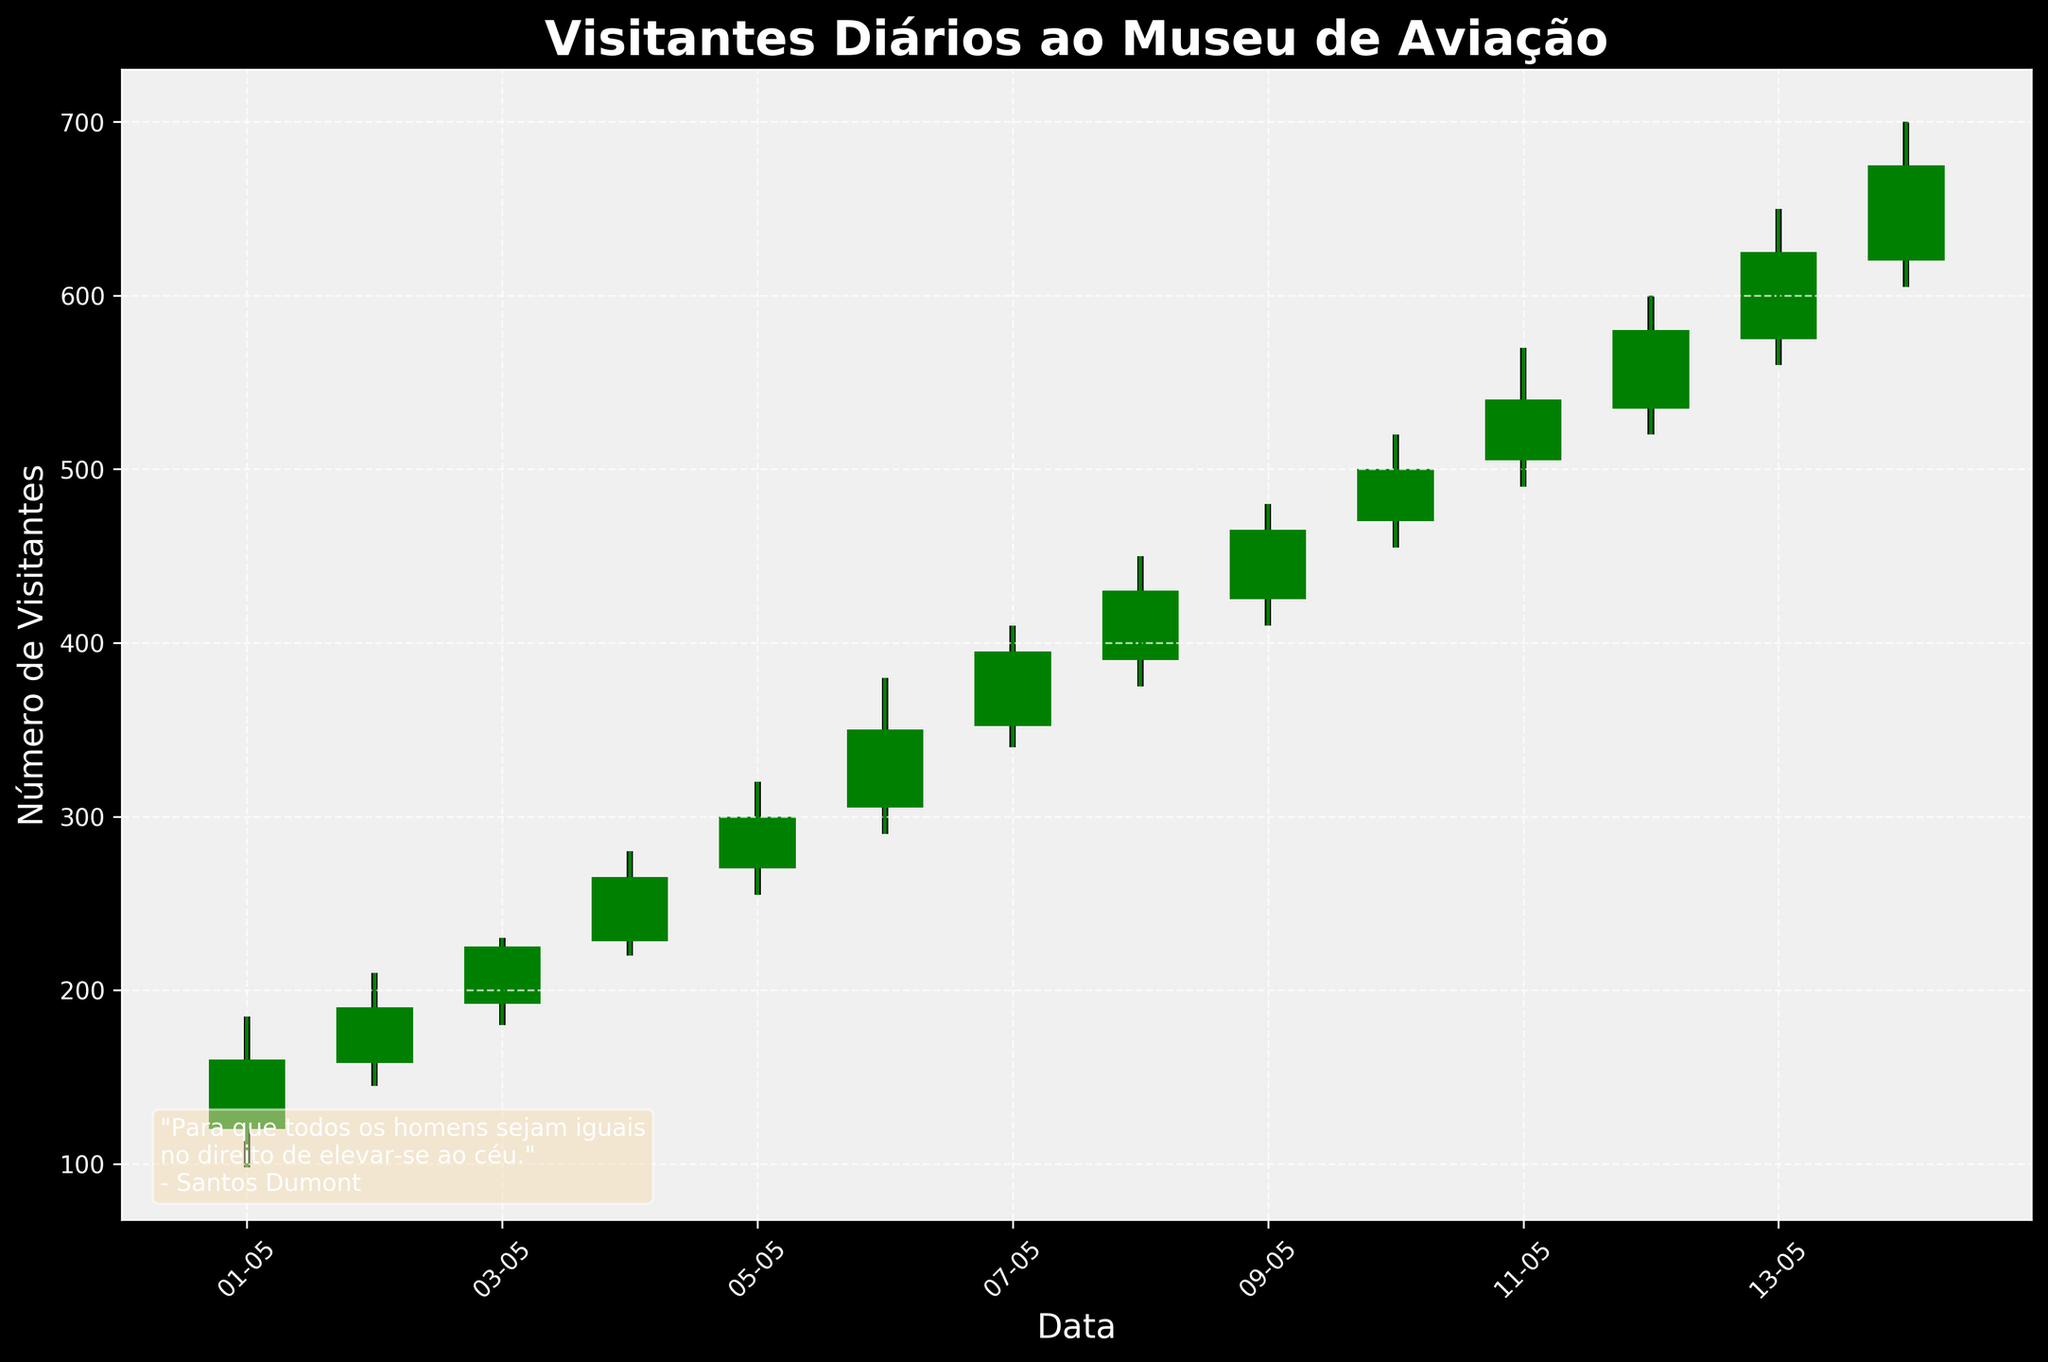What is the title of the chart? The title of the chart is usually found at the top. In this chart, it reads "Visitantes Diários ao Museu de Aviação".
Answer: Visitantes Diários ao Museu de Aviação Which day had the highest number of visitors? To find the highest number of visitors, look for the tallest point on the chart. The highest point is on 2023-05-14 with a high of 700 visitors.
Answer: 2023-05-14 On which day did the closing number of visitors exceed the opening number of visitors the most? To find this, calculate the difference between closing and opening numbers for each day and identify which day has the highest difference. The day with the highest difference (675 - 620 = 55) is 2023-05-14.
Answer: 2023-05-14 What was the lowest number of visitors on 2023-05-06? The lowest number of visitors for a particular day can be found by looking at the 'Low' value. For 2023-05-06, the lowest visitor count was 290.
Answer: 290 Which date(s) show a decrease in visitor numbers from open to close? Visitor numbers decrease if the closing number is less than the opening number. This is shown by red bars. Here, 2023-05-01 is red due to a close of 160 from an open of 120.
Answer: 2023-05-01 Calculate the total increase in visitor numbers from 2023-05-01 to 2023-05-14. Calculate the difference between the close of 2023-05-14 and the open of 2023-05-01. Total increase = 675 - 120 = 555.
Answer: 555 Which date had the smallest range of visitor counts (high minus low)? Calculate the range (high - low) for each day and find the smallest. On 2023-05-12, the range is smallest with a high of 600 and low of 520, range = 80.
Answer: 2023-05-12 What is the average of the opening numbers from 2023-05-01 to 2023-05-14? Sum all the opening numbers and divide by the number of days (14). Average = (120 + 158 + 192 + 228 + 270 + 305 + 352 + 390 + 425 + 470 + 505 + 535 + 575 + 620)/14 = 408.214 ≈ 408.
Answer: 408 